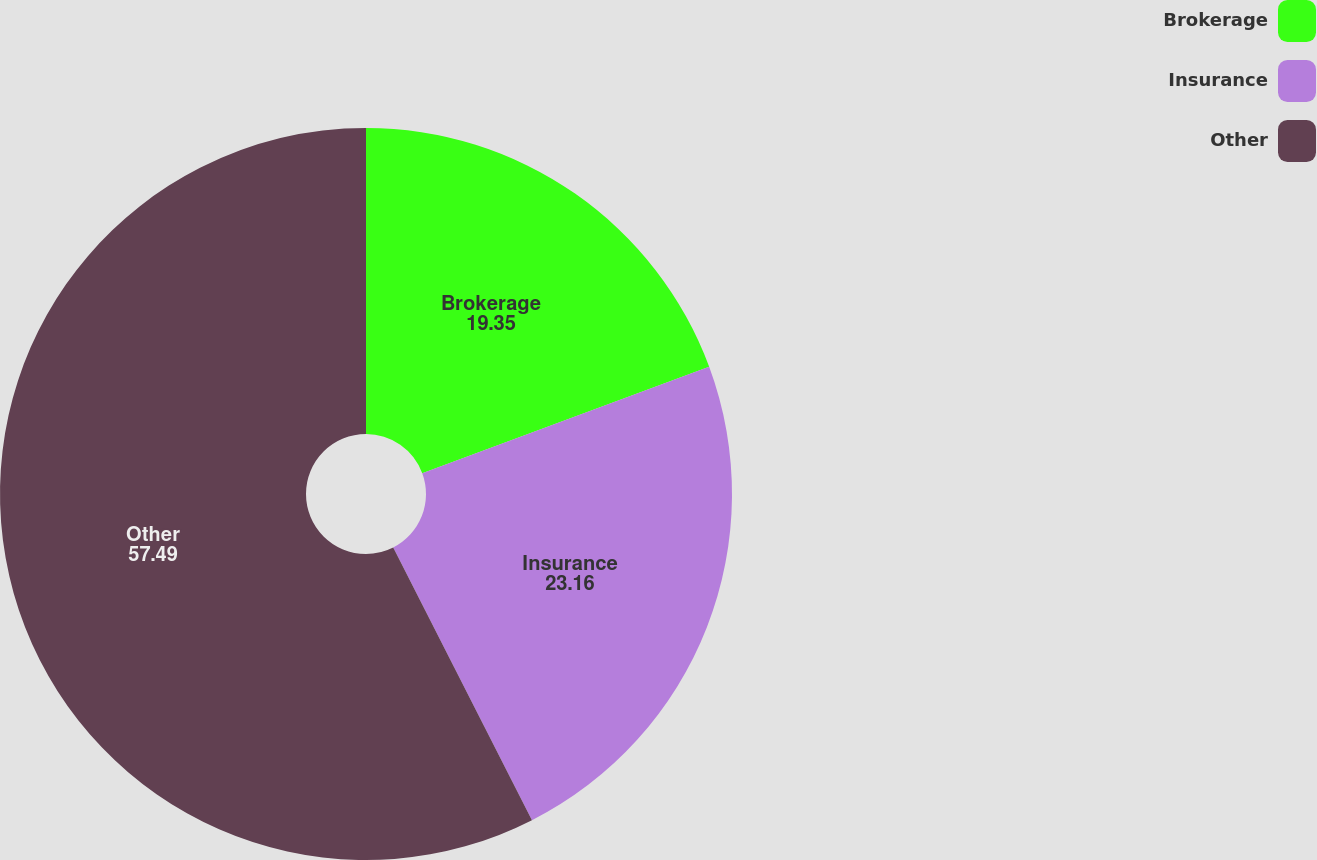Convert chart to OTSL. <chart><loc_0><loc_0><loc_500><loc_500><pie_chart><fcel>Brokerage<fcel>Insurance<fcel>Other<nl><fcel>19.35%<fcel>23.16%<fcel>57.49%<nl></chart> 